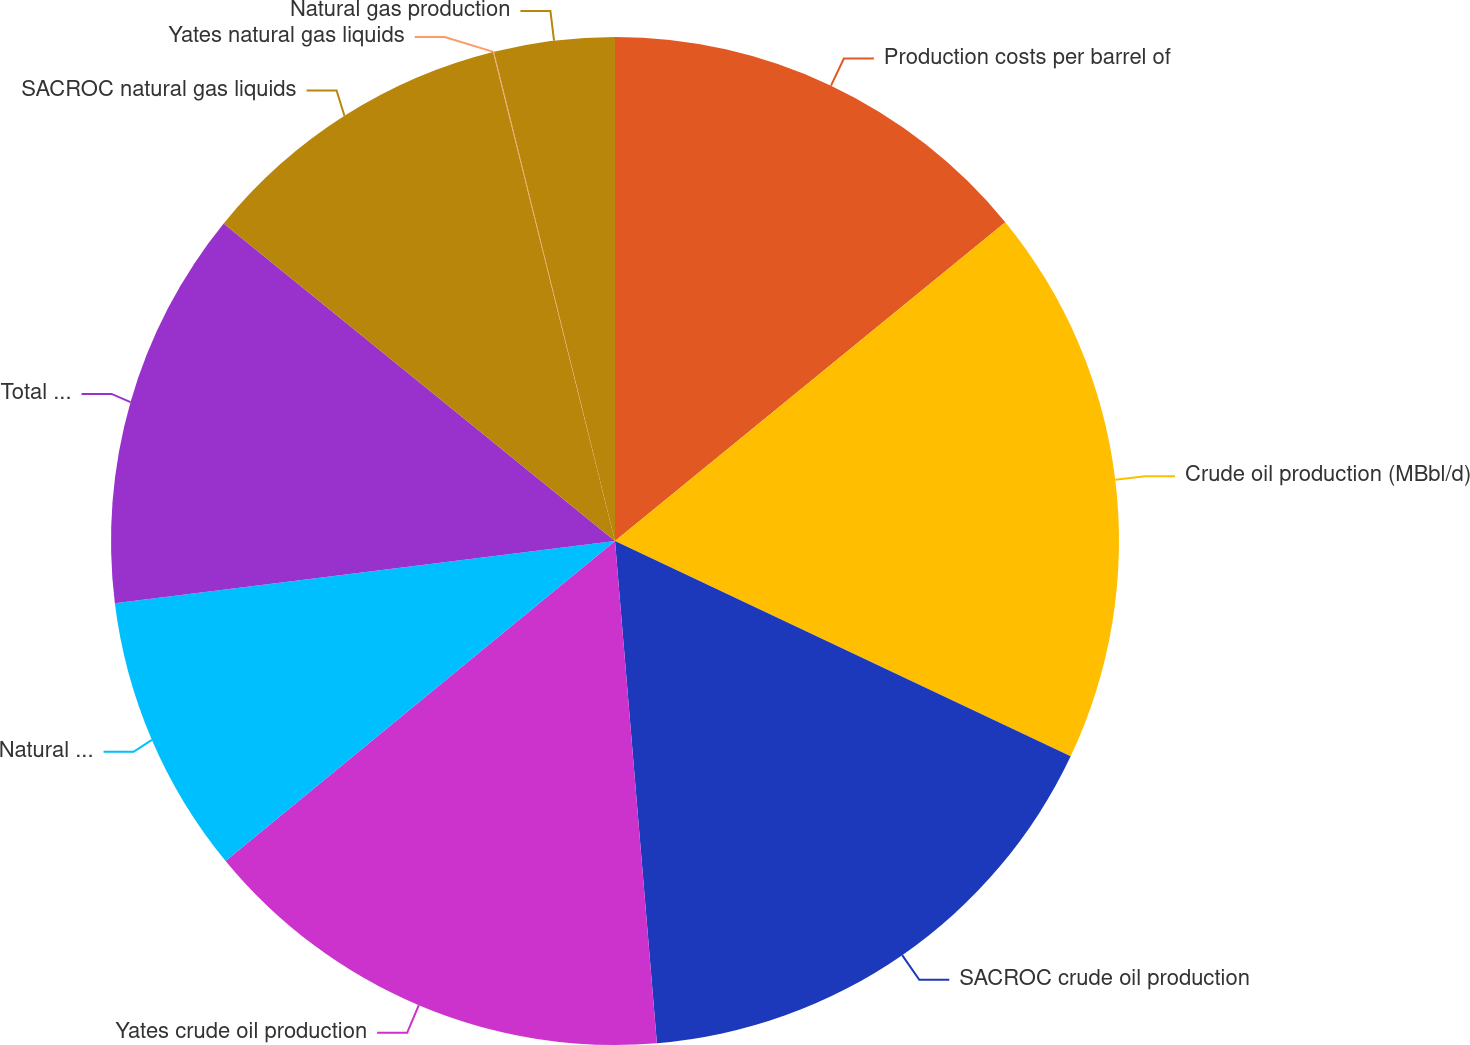<chart> <loc_0><loc_0><loc_500><loc_500><pie_chart><fcel>Production costs per barrel of<fcel>Crude oil production (MBbl/d)<fcel>SACROC crude oil production<fcel>Yates crude oil production<fcel>Natural gas liquids production<fcel>Total natural gas liquids<fcel>SACROC natural gas liquids<fcel>Yates natural gas liquids<fcel>Natural gas production<nl><fcel>14.1%<fcel>17.93%<fcel>16.65%<fcel>15.38%<fcel>8.98%<fcel>12.82%<fcel>10.26%<fcel>0.03%<fcel>3.86%<nl></chart> 